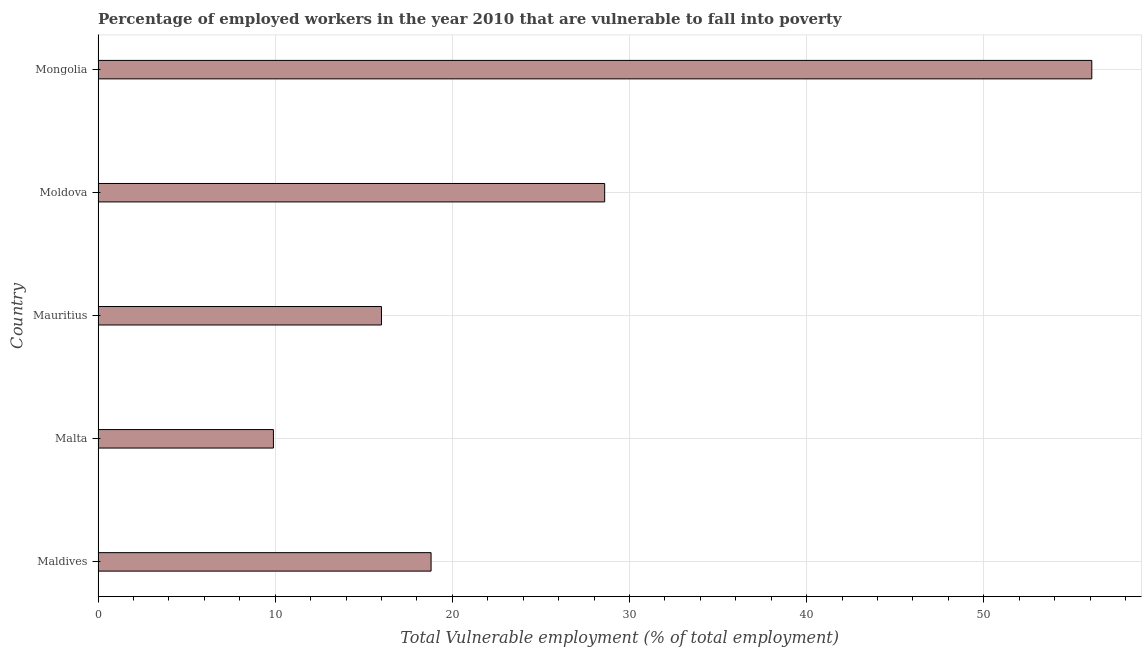Does the graph contain grids?
Your answer should be compact. Yes. What is the title of the graph?
Give a very brief answer. Percentage of employed workers in the year 2010 that are vulnerable to fall into poverty. What is the label or title of the X-axis?
Keep it short and to the point. Total Vulnerable employment (% of total employment). What is the total vulnerable employment in Mongolia?
Your response must be concise. 56.1. Across all countries, what is the maximum total vulnerable employment?
Your answer should be very brief. 56.1. Across all countries, what is the minimum total vulnerable employment?
Your answer should be compact. 9.9. In which country was the total vulnerable employment maximum?
Your response must be concise. Mongolia. In which country was the total vulnerable employment minimum?
Ensure brevity in your answer.  Malta. What is the sum of the total vulnerable employment?
Your answer should be compact. 129.4. What is the difference between the total vulnerable employment in Malta and Moldova?
Your response must be concise. -18.7. What is the average total vulnerable employment per country?
Your answer should be very brief. 25.88. What is the median total vulnerable employment?
Offer a very short reply. 18.8. What is the ratio of the total vulnerable employment in Mauritius to that in Mongolia?
Your answer should be compact. 0.28. Is the total vulnerable employment in Mauritius less than that in Moldova?
Your answer should be very brief. Yes. What is the difference between the highest and the second highest total vulnerable employment?
Make the answer very short. 27.5. Is the sum of the total vulnerable employment in Moldova and Mongolia greater than the maximum total vulnerable employment across all countries?
Keep it short and to the point. Yes. What is the difference between the highest and the lowest total vulnerable employment?
Make the answer very short. 46.2. How many countries are there in the graph?
Provide a short and direct response. 5. What is the Total Vulnerable employment (% of total employment) of Maldives?
Your response must be concise. 18.8. What is the Total Vulnerable employment (% of total employment) of Malta?
Provide a succinct answer. 9.9. What is the Total Vulnerable employment (% of total employment) of Moldova?
Ensure brevity in your answer.  28.6. What is the Total Vulnerable employment (% of total employment) of Mongolia?
Ensure brevity in your answer.  56.1. What is the difference between the Total Vulnerable employment (% of total employment) in Maldives and Mongolia?
Provide a short and direct response. -37.3. What is the difference between the Total Vulnerable employment (% of total employment) in Malta and Moldova?
Ensure brevity in your answer.  -18.7. What is the difference between the Total Vulnerable employment (% of total employment) in Malta and Mongolia?
Give a very brief answer. -46.2. What is the difference between the Total Vulnerable employment (% of total employment) in Mauritius and Mongolia?
Offer a terse response. -40.1. What is the difference between the Total Vulnerable employment (% of total employment) in Moldova and Mongolia?
Keep it short and to the point. -27.5. What is the ratio of the Total Vulnerable employment (% of total employment) in Maldives to that in Malta?
Keep it short and to the point. 1.9. What is the ratio of the Total Vulnerable employment (% of total employment) in Maldives to that in Mauritius?
Provide a short and direct response. 1.18. What is the ratio of the Total Vulnerable employment (% of total employment) in Maldives to that in Moldova?
Ensure brevity in your answer.  0.66. What is the ratio of the Total Vulnerable employment (% of total employment) in Maldives to that in Mongolia?
Keep it short and to the point. 0.34. What is the ratio of the Total Vulnerable employment (% of total employment) in Malta to that in Mauritius?
Your answer should be very brief. 0.62. What is the ratio of the Total Vulnerable employment (% of total employment) in Malta to that in Moldova?
Your answer should be compact. 0.35. What is the ratio of the Total Vulnerable employment (% of total employment) in Malta to that in Mongolia?
Provide a short and direct response. 0.18. What is the ratio of the Total Vulnerable employment (% of total employment) in Mauritius to that in Moldova?
Provide a short and direct response. 0.56. What is the ratio of the Total Vulnerable employment (% of total employment) in Mauritius to that in Mongolia?
Make the answer very short. 0.28. What is the ratio of the Total Vulnerable employment (% of total employment) in Moldova to that in Mongolia?
Ensure brevity in your answer.  0.51. 